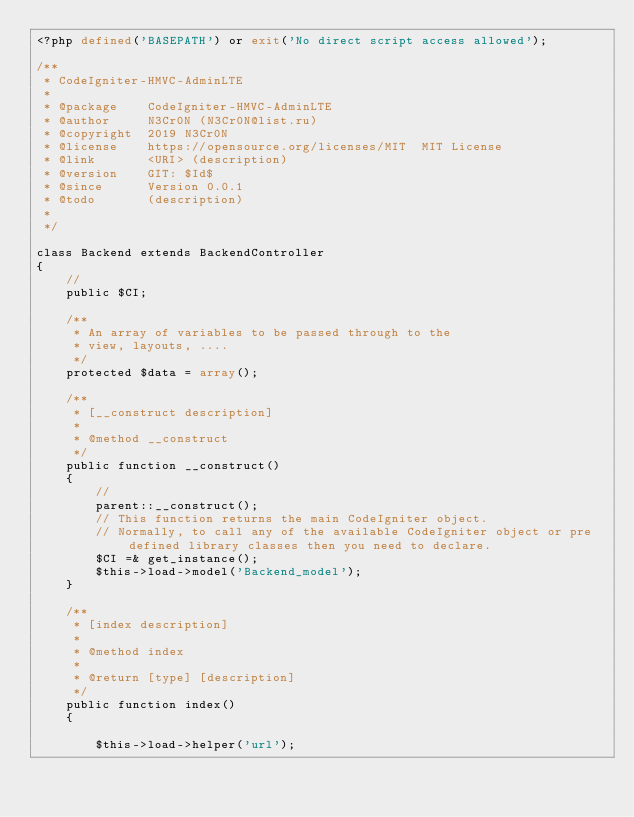Convert code to text. <code><loc_0><loc_0><loc_500><loc_500><_PHP_><?php defined('BASEPATH') or exit('No direct script access allowed');

/**
 * CodeIgniter-HMVC-AdminLTE
 *
 * @package    CodeIgniter-HMVC-AdminLTE
 * @author     N3Cr0N (N3Cr0N@list.ru)
 * @copyright  2019 N3Cr0N
 * @license    https://opensource.org/licenses/MIT  MIT License
 * @link       <URI> (description)
 * @version    GIT: $Id$
 * @since      Version 0.0.1
 * @todo       (description)
 *
 */

class Backend extends BackendController
{
    //
    public $CI;

    /**
     * An array of variables to be passed through to the
     * view, layouts, ....
     */
    protected $data = array();

    /**
     * [__construct description]
     *
     * @method __construct
     */
    public function __construct()
    {
        //
        parent::__construct();
        // This function returns the main CodeIgniter object.
        // Normally, to call any of the available CodeIgniter object or pre defined library classes then you need to declare.
        $CI =& get_instance();
		$this->load->model('Backend_model');
    }

    /**
     * [index description]
     *
     * @method index
     *
     * @return [type] [description]
     */
    public function index()
    {
		
		$this->load->helper('url');</code> 